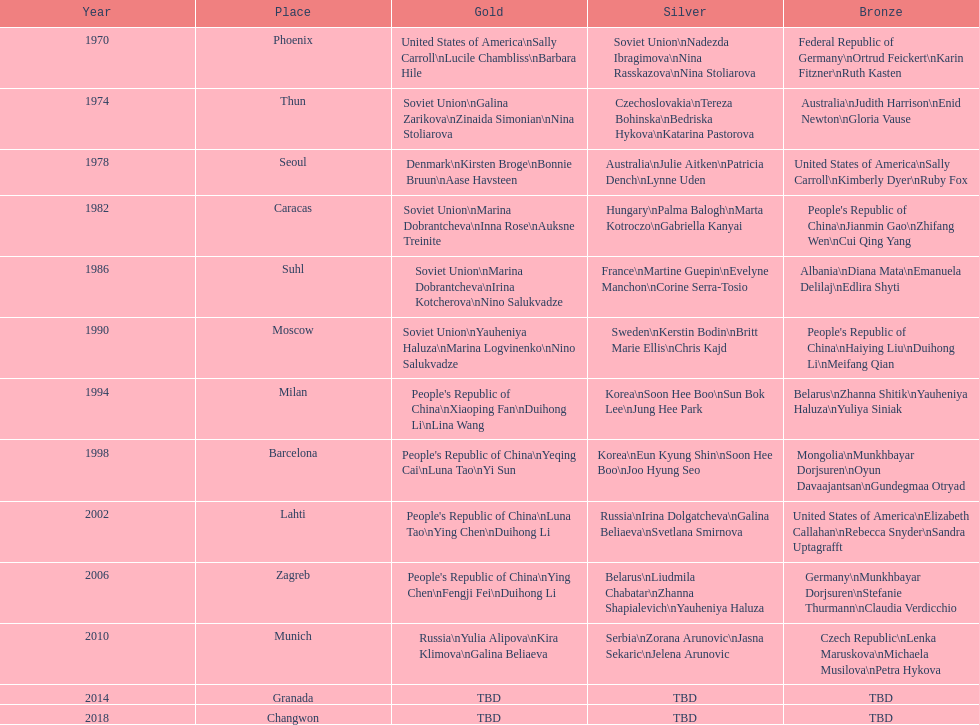Can you parse all the data within this table? {'header': ['Year', 'Place', 'Gold', 'Silver', 'Bronze'], 'rows': [['1970', 'Phoenix', 'United States of America\\nSally Carroll\\nLucile Chambliss\\nBarbara Hile', 'Soviet Union\\nNadezda Ibragimova\\nNina Rasskazova\\nNina Stoliarova', 'Federal Republic of Germany\\nOrtrud Feickert\\nKarin Fitzner\\nRuth Kasten'], ['1974', 'Thun', 'Soviet Union\\nGalina Zarikova\\nZinaida Simonian\\nNina Stoliarova', 'Czechoslovakia\\nTereza Bohinska\\nBedriska Hykova\\nKatarina Pastorova', 'Australia\\nJudith Harrison\\nEnid Newton\\nGloria Vause'], ['1978', 'Seoul', 'Denmark\\nKirsten Broge\\nBonnie Bruun\\nAase Havsteen', 'Australia\\nJulie Aitken\\nPatricia Dench\\nLynne Uden', 'United States of America\\nSally Carroll\\nKimberly Dyer\\nRuby Fox'], ['1982', 'Caracas', 'Soviet Union\\nMarina Dobrantcheva\\nInna Rose\\nAuksne Treinite', 'Hungary\\nPalma Balogh\\nMarta Kotroczo\\nGabriella Kanyai', "People's Republic of China\\nJianmin Gao\\nZhifang Wen\\nCui Qing Yang"], ['1986', 'Suhl', 'Soviet Union\\nMarina Dobrantcheva\\nIrina Kotcherova\\nNino Salukvadze', 'France\\nMartine Guepin\\nEvelyne Manchon\\nCorine Serra-Tosio', 'Albania\\nDiana Mata\\nEmanuela Delilaj\\nEdlira Shyti'], ['1990', 'Moscow', 'Soviet Union\\nYauheniya Haluza\\nMarina Logvinenko\\nNino Salukvadze', 'Sweden\\nKerstin Bodin\\nBritt Marie Ellis\\nChris Kajd', "People's Republic of China\\nHaiying Liu\\nDuihong Li\\nMeifang Qian"], ['1994', 'Milan', "People's Republic of China\\nXiaoping Fan\\nDuihong Li\\nLina Wang", 'Korea\\nSoon Hee Boo\\nSun Bok Lee\\nJung Hee Park', 'Belarus\\nZhanna Shitik\\nYauheniya Haluza\\nYuliya Siniak'], ['1998', 'Barcelona', "People's Republic of China\\nYeqing Cai\\nLuna Tao\\nYi Sun", 'Korea\\nEun Kyung Shin\\nSoon Hee Boo\\nJoo Hyung Seo', 'Mongolia\\nMunkhbayar Dorjsuren\\nOyun Davaajantsan\\nGundegmaa Otryad'], ['2002', 'Lahti', "People's Republic of China\\nLuna Tao\\nYing Chen\\nDuihong Li", 'Russia\\nIrina Dolgatcheva\\nGalina Beliaeva\\nSvetlana Smirnova', 'United States of America\\nElizabeth Callahan\\nRebecca Snyder\\nSandra Uptagrafft'], ['2006', 'Zagreb', "People's Republic of China\\nYing Chen\\nFengji Fei\\nDuihong Li", 'Belarus\\nLiudmila Chabatar\\nZhanna Shapialevich\\nYauheniya Haluza', 'Germany\\nMunkhbayar Dorjsuren\\nStefanie Thurmann\\nClaudia Verdicchio'], ['2010', 'Munich', 'Russia\\nYulia Alipova\\nKira Klimova\\nGalina Beliaeva', 'Serbia\\nZorana Arunovic\\nJasna Sekaric\\nJelena Arunovic', 'Czech Republic\\nLenka Maruskova\\nMichaela Musilova\\nPetra Hykova'], ['2014', 'Granada', 'TBD', 'TBD', 'TBD'], ['2018', 'Changwon', 'TBD', 'TBD', 'TBD']]} How many times has germany won bronze? 2. 